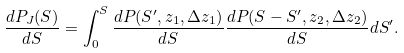Convert formula to latex. <formula><loc_0><loc_0><loc_500><loc_500>\frac { d P _ { J } ( S ) } { d S } = \int _ { 0 } ^ { S } \frac { d P ( S ^ { \prime } , z _ { 1 } , \Delta z _ { 1 } ) } { d S } \frac { d P ( S - S ^ { \prime } , z _ { 2 } , \Delta z _ { 2 } ) } { d S } d S ^ { \prime } .</formula> 